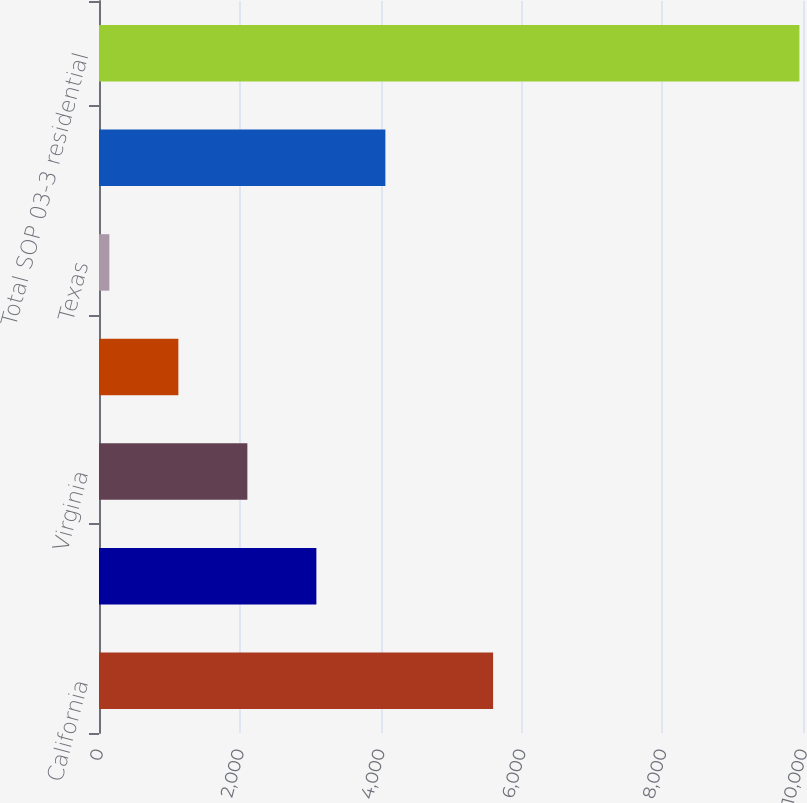Convert chart. <chart><loc_0><loc_0><loc_500><loc_500><bar_chart><fcel>California<fcel>Florida<fcel>Virginia<fcel>Maryland<fcel>Texas<fcel>Other US / Foreign<fcel>Total SOP 03-3 residential<nl><fcel>5598<fcel>3087.6<fcel>2107.4<fcel>1127.2<fcel>147<fcel>4067.8<fcel>9949<nl></chart> 